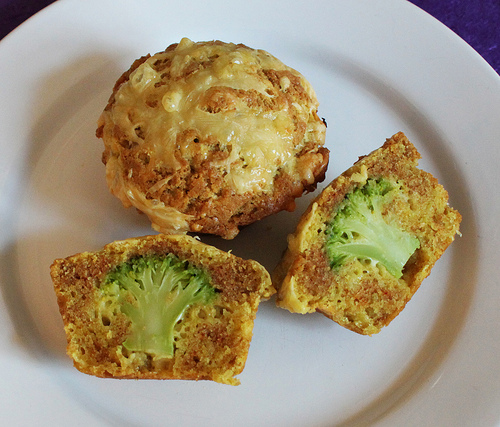<image>
Is the food under the muffin? No. The food is not positioned under the muffin. The vertical relationship between these objects is different. Where is the brocolli in relation to the muffin? Is it in the muffin? Yes. The brocolli is contained within or inside the muffin, showing a containment relationship. Is there a broccoli in the muffin? Yes. The broccoli is contained within or inside the muffin, showing a containment relationship. 